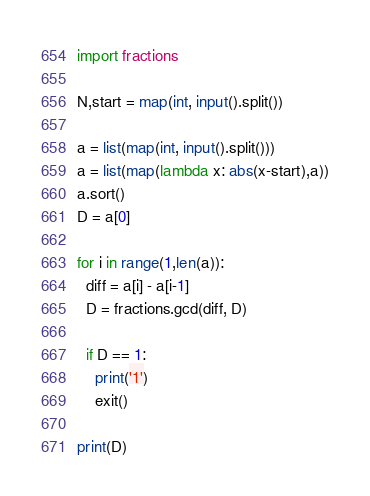Convert code to text. <code><loc_0><loc_0><loc_500><loc_500><_Python_>import fractions

N,start = map(int, input().split())

a = list(map(int, input().split()))
a = list(map(lambda x: abs(x-start),a))
a.sort()
D = a[0]

for i in range(1,len(a)):
  diff = a[i] - a[i-1]
  D = fractions.gcd(diff, D)

  if D == 1:
    print('1')
    exit()

print(D)
</code> 